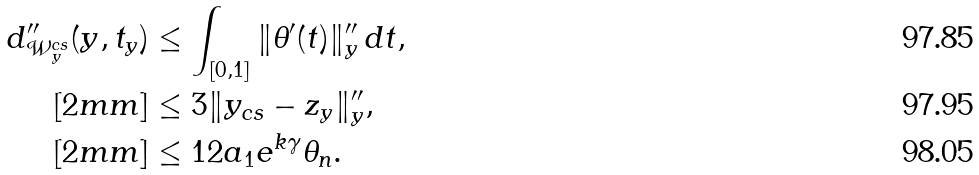<formula> <loc_0><loc_0><loc_500><loc_500>d ^ { \prime \prime } _ { \mathcal { W } ^ { c s } _ { y } } ( y , t _ { y } ) & \leq \int _ { [ 0 , 1 ] } \| \theta ^ { \prime } ( t ) \| ^ { \prime \prime } _ { y } \, d t , \\ [ 2 m m ] & \leq 3 \| y _ { c s } - z _ { y } \| ^ { \prime \prime } _ { y } , \\ [ 2 m m ] & \leq 1 2 a _ { 1 } e ^ { k \gamma } \theta _ { n } .</formula> 